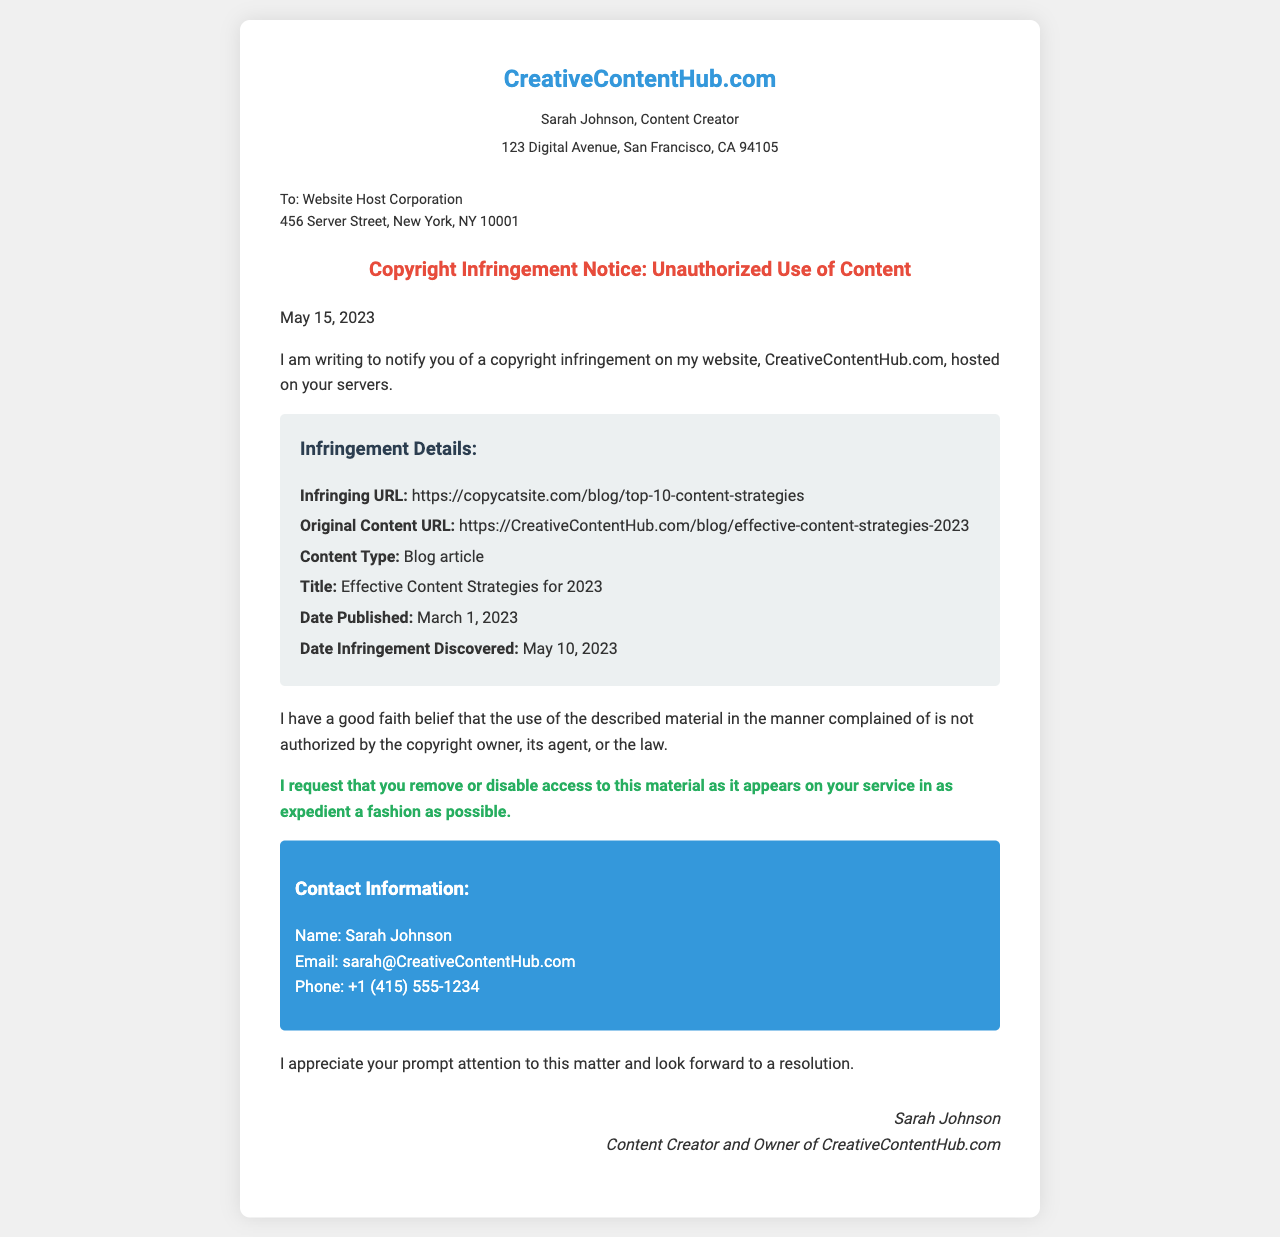What is the sender's name? The sender's name is mentioned in the document under the sender information section.
Answer: Sarah Johnson What is the date of the copyright infringement notice? The date is specified in the opening paragraph of the content section.
Answer: May 15, 2023 What is the infringing URL? This URL is provided in the infringement details section.
Answer: https://copycatsite.com/blog/top-10-content-strategies What is the original content URL? The original content URL is also listed in the infringement details section.
Answer: https://CreativeContentHub.com/blog/effective-content-strategies-2023 What type of content is being infringed? The content type is clearly stated in the infringement details.
Answer: Blog article What is the title of the original content? The title is given within the infringement details section of the document.
Answer: Effective Content Strategies for 2023 What action is being requested in the notice? The requested action is mentioned in the document as a specific request.
Answer: Remove or disable access to this material When was the original content published? The publication date of the original content is listed in the infringement details section.
Answer: March 1, 2023 Who is the recipient of the fax? The recipient is mentioned at the beginning of the document where the recipient information is provided.
Answer: Website Host Corporation What is the contact email of the sender? The contact email is provided in the contact information section.
Answer: sarah@CreativeContentHub.com 